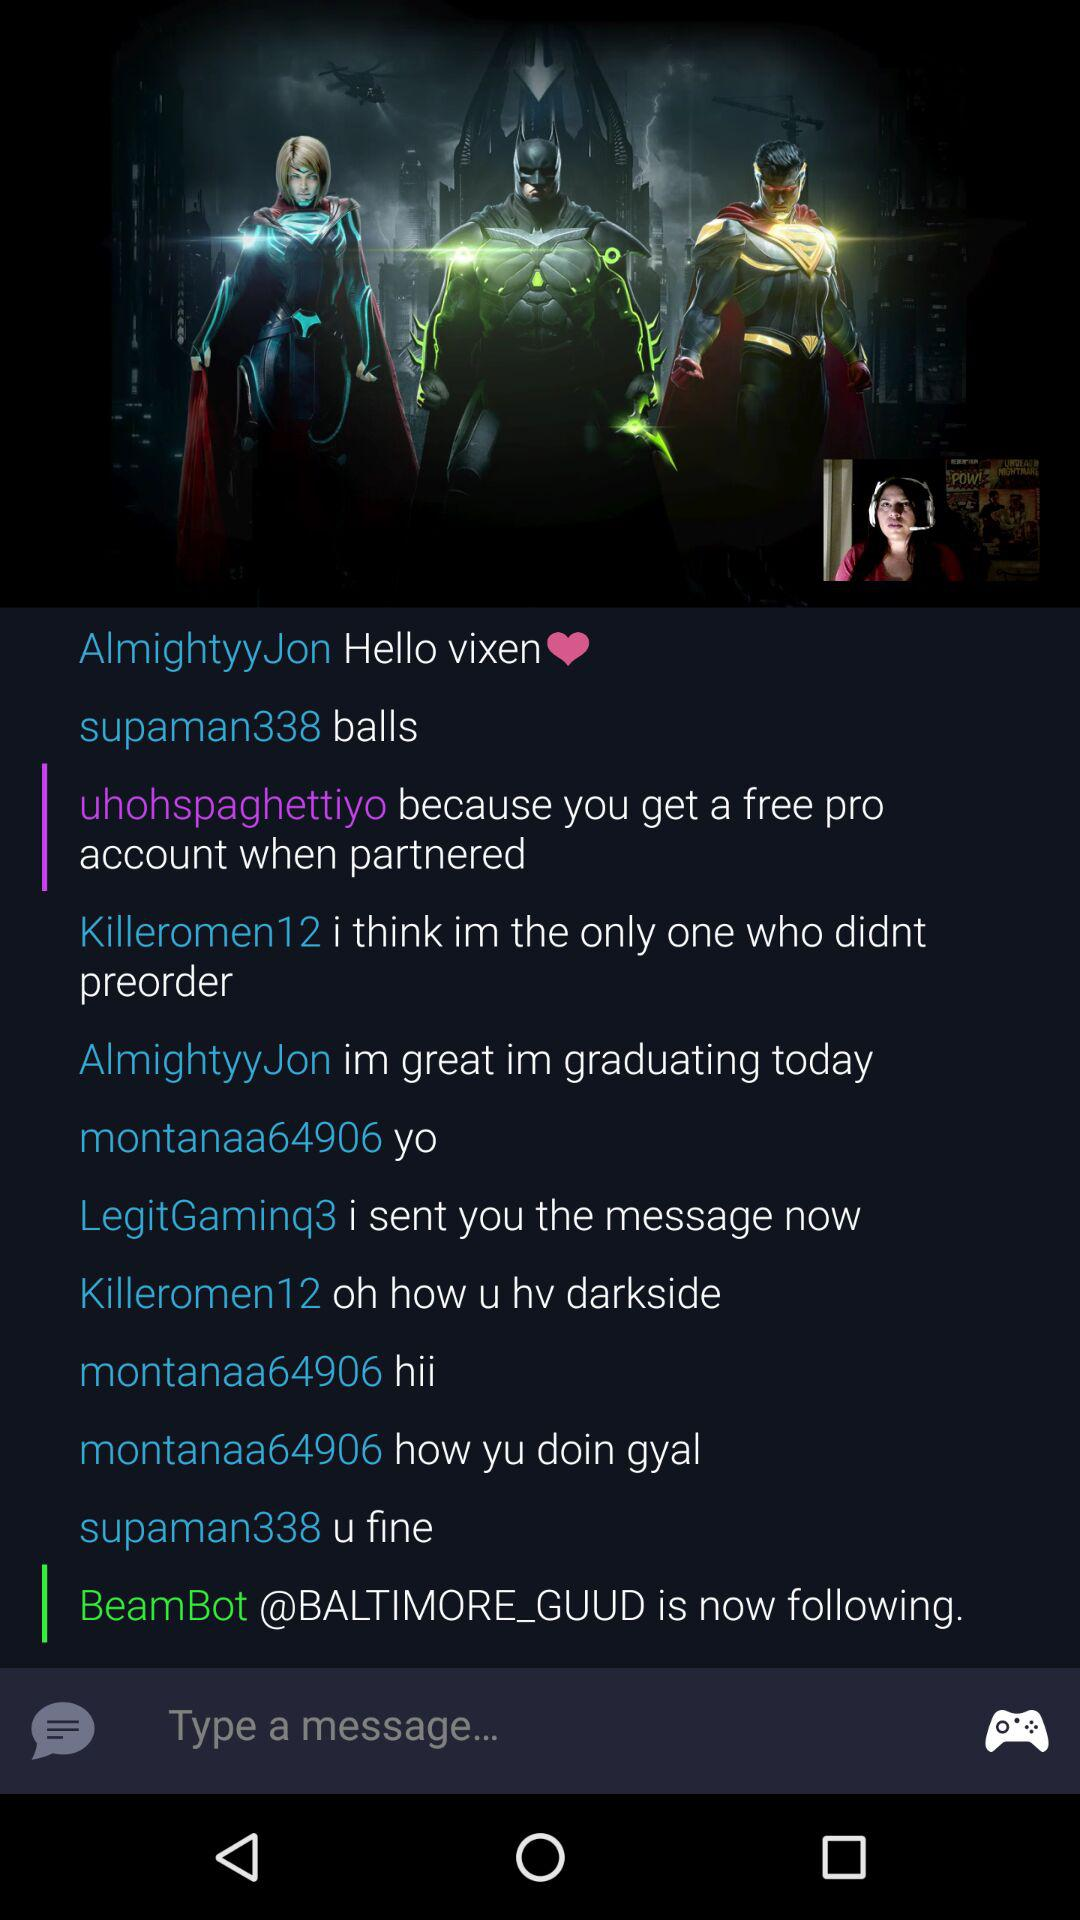How many people are in the chat?
Answer the question using a single word or phrase. 7 